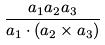Convert formula to latex. <formula><loc_0><loc_0><loc_500><loc_500>\frac { a _ { 1 } a _ { 2 } a _ { 3 } } { a _ { 1 } \cdot ( a _ { 2 } \times a _ { 3 } ) }</formula> 